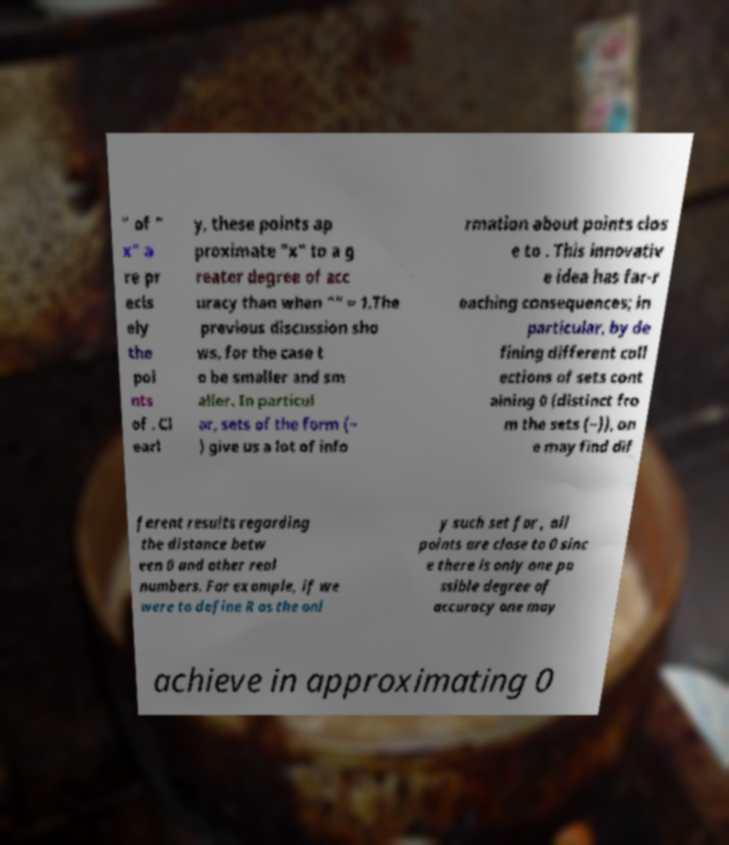Could you assist in decoding the text presented in this image and type it out clearly? " of " x" a re pr ecis ely the poi nts of . Cl earl y, these points ap proximate "x" to a g reater degree of acc uracy than when "" = 1.The previous discussion sho ws, for the case t o be smaller and sm aller. In particul ar, sets of the form (− ) give us a lot of info rmation about points clos e to . This innovativ e idea has far-r eaching consequences; in particular, by de fining different coll ections of sets cont aining 0 (distinct fro m the sets (−)), on e may find dif ferent results regarding the distance betw een 0 and other real numbers. For example, if we were to define R as the onl y such set for , all points are close to 0 sinc e there is only one po ssible degree of accuracy one may achieve in approximating 0 